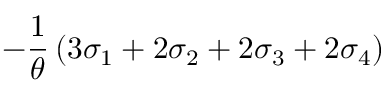Convert formula to latex. <formula><loc_0><loc_0><loc_500><loc_500>- \frac { 1 } { \theta } \left ( 3 \sigma _ { 1 } + 2 \sigma _ { 2 } + 2 \sigma _ { 3 } + 2 \sigma _ { 4 } \right )</formula> 